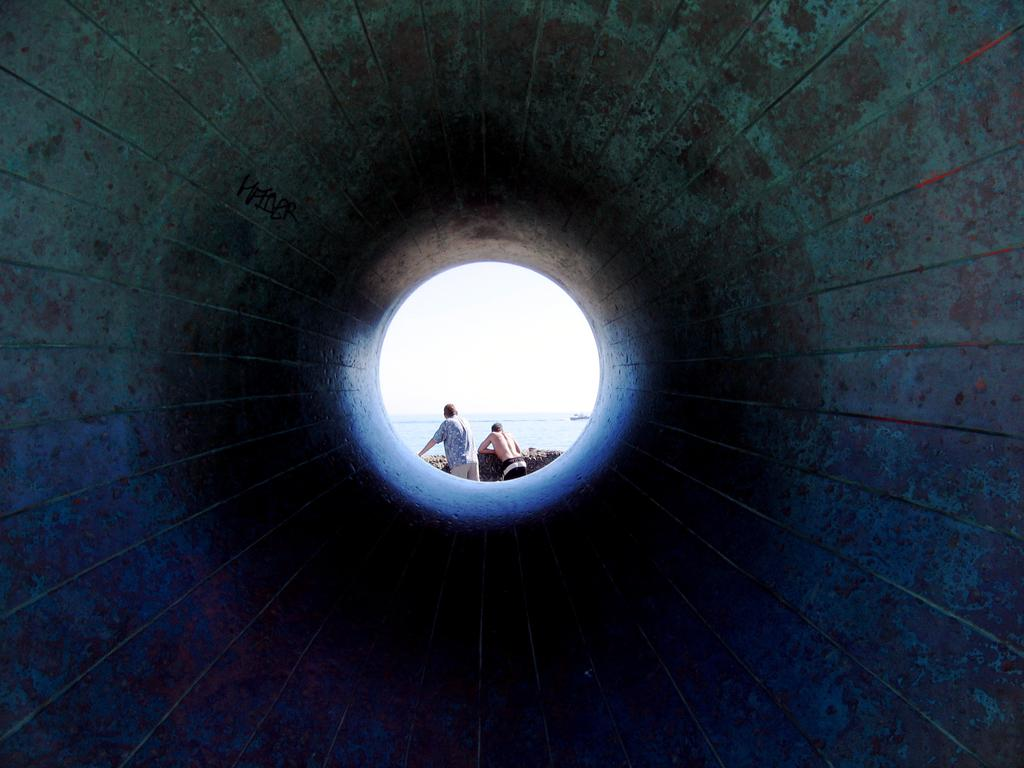How many people are present in the image? There are two people standing in the image. What is the setting of the image? The image features water and a ship, suggesting it is a maritime scene. What is the color of the sky in the image? The sky appears to be white in color. What part of a structure can be seen in the image? The inner part of a pipe is visible in the image. What type of chain can be seen connecting the two people in the image? There is no chain connecting the two people in the image; they are simply standing near each other. 